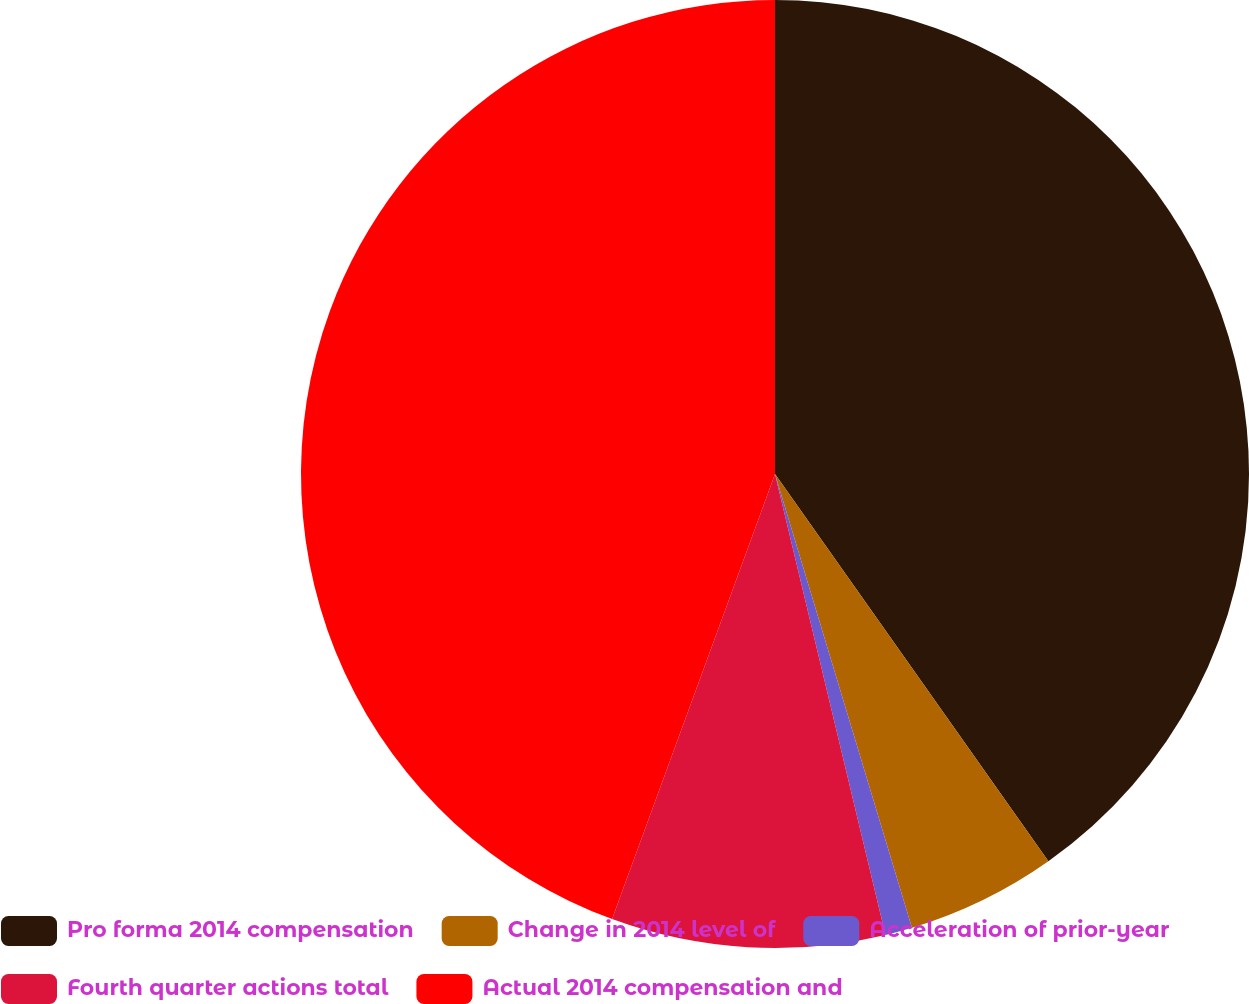Convert chart to OTSL. <chart><loc_0><loc_0><loc_500><loc_500><pie_chart><fcel>Pro forma 2014 compensation<fcel>Change in 2014 level of<fcel>Acceleration of prior-year<fcel>Fourth quarter actions total<fcel>Actual 2014 compensation and<nl><fcel>40.22%<fcel>5.12%<fcel>0.92%<fcel>9.33%<fcel>44.42%<nl></chart> 